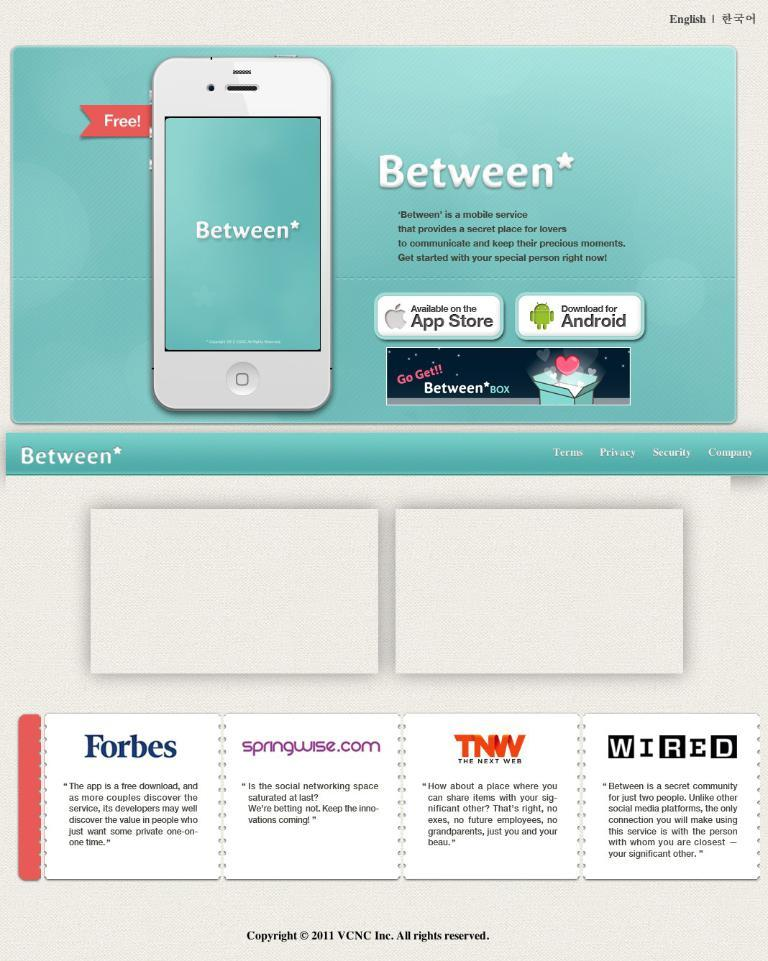<image>
Write a terse but informative summary of the picture. An ad for a mobile service that is called Between. 